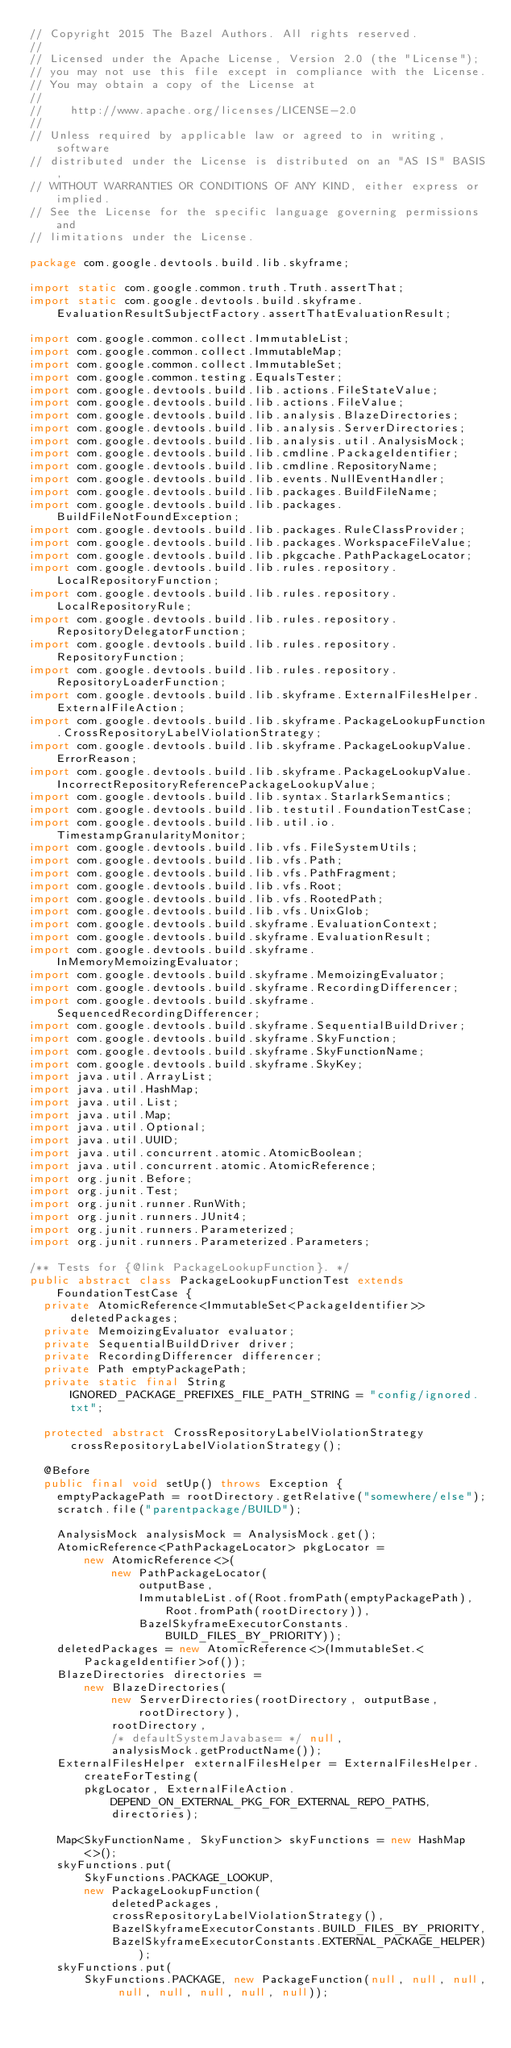Convert code to text. <code><loc_0><loc_0><loc_500><loc_500><_Java_>// Copyright 2015 The Bazel Authors. All rights reserved.
//
// Licensed under the Apache License, Version 2.0 (the "License");
// you may not use this file except in compliance with the License.
// You may obtain a copy of the License at
//
//    http://www.apache.org/licenses/LICENSE-2.0
//
// Unless required by applicable law or agreed to in writing, software
// distributed under the License is distributed on an "AS IS" BASIS,
// WITHOUT WARRANTIES OR CONDITIONS OF ANY KIND, either express or implied.
// See the License for the specific language governing permissions and
// limitations under the License.

package com.google.devtools.build.lib.skyframe;

import static com.google.common.truth.Truth.assertThat;
import static com.google.devtools.build.skyframe.EvaluationResultSubjectFactory.assertThatEvaluationResult;

import com.google.common.collect.ImmutableList;
import com.google.common.collect.ImmutableMap;
import com.google.common.collect.ImmutableSet;
import com.google.common.testing.EqualsTester;
import com.google.devtools.build.lib.actions.FileStateValue;
import com.google.devtools.build.lib.actions.FileValue;
import com.google.devtools.build.lib.analysis.BlazeDirectories;
import com.google.devtools.build.lib.analysis.ServerDirectories;
import com.google.devtools.build.lib.analysis.util.AnalysisMock;
import com.google.devtools.build.lib.cmdline.PackageIdentifier;
import com.google.devtools.build.lib.cmdline.RepositoryName;
import com.google.devtools.build.lib.events.NullEventHandler;
import com.google.devtools.build.lib.packages.BuildFileName;
import com.google.devtools.build.lib.packages.BuildFileNotFoundException;
import com.google.devtools.build.lib.packages.RuleClassProvider;
import com.google.devtools.build.lib.packages.WorkspaceFileValue;
import com.google.devtools.build.lib.pkgcache.PathPackageLocator;
import com.google.devtools.build.lib.rules.repository.LocalRepositoryFunction;
import com.google.devtools.build.lib.rules.repository.LocalRepositoryRule;
import com.google.devtools.build.lib.rules.repository.RepositoryDelegatorFunction;
import com.google.devtools.build.lib.rules.repository.RepositoryFunction;
import com.google.devtools.build.lib.rules.repository.RepositoryLoaderFunction;
import com.google.devtools.build.lib.skyframe.ExternalFilesHelper.ExternalFileAction;
import com.google.devtools.build.lib.skyframe.PackageLookupFunction.CrossRepositoryLabelViolationStrategy;
import com.google.devtools.build.lib.skyframe.PackageLookupValue.ErrorReason;
import com.google.devtools.build.lib.skyframe.PackageLookupValue.IncorrectRepositoryReferencePackageLookupValue;
import com.google.devtools.build.lib.syntax.StarlarkSemantics;
import com.google.devtools.build.lib.testutil.FoundationTestCase;
import com.google.devtools.build.lib.util.io.TimestampGranularityMonitor;
import com.google.devtools.build.lib.vfs.FileSystemUtils;
import com.google.devtools.build.lib.vfs.Path;
import com.google.devtools.build.lib.vfs.PathFragment;
import com.google.devtools.build.lib.vfs.Root;
import com.google.devtools.build.lib.vfs.RootedPath;
import com.google.devtools.build.lib.vfs.UnixGlob;
import com.google.devtools.build.skyframe.EvaluationContext;
import com.google.devtools.build.skyframe.EvaluationResult;
import com.google.devtools.build.skyframe.InMemoryMemoizingEvaluator;
import com.google.devtools.build.skyframe.MemoizingEvaluator;
import com.google.devtools.build.skyframe.RecordingDifferencer;
import com.google.devtools.build.skyframe.SequencedRecordingDifferencer;
import com.google.devtools.build.skyframe.SequentialBuildDriver;
import com.google.devtools.build.skyframe.SkyFunction;
import com.google.devtools.build.skyframe.SkyFunctionName;
import com.google.devtools.build.skyframe.SkyKey;
import java.util.ArrayList;
import java.util.HashMap;
import java.util.List;
import java.util.Map;
import java.util.Optional;
import java.util.UUID;
import java.util.concurrent.atomic.AtomicBoolean;
import java.util.concurrent.atomic.AtomicReference;
import org.junit.Before;
import org.junit.Test;
import org.junit.runner.RunWith;
import org.junit.runners.JUnit4;
import org.junit.runners.Parameterized;
import org.junit.runners.Parameterized.Parameters;

/** Tests for {@link PackageLookupFunction}. */
public abstract class PackageLookupFunctionTest extends FoundationTestCase {
  private AtomicReference<ImmutableSet<PackageIdentifier>> deletedPackages;
  private MemoizingEvaluator evaluator;
  private SequentialBuildDriver driver;
  private RecordingDifferencer differencer;
  private Path emptyPackagePath;
  private static final String IGNORED_PACKAGE_PREFIXES_FILE_PATH_STRING = "config/ignored.txt";

  protected abstract CrossRepositoryLabelViolationStrategy crossRepositoryLabelViolationStrategy();

  @Before
  public final void setUp() throws Exception {
    emptyPackagePath = rootDirectory.getRelative("somewhere/else");
    scratch.file("parentpackage/BUILD");

    AnalysisMock analysisMock = AnalysisMock.get();
    AtomicReference<PathPackageLocator> pkgLocator =
        new AtomicReference<>(
            new PathPackageLocator(
                outputBase,
                ImmutableList.of(Root.fromPath(emptyPackagePath), Root.fromPath(rootDirectory)),
                BazelSkyframeExecutorConstants.BUILD_FILES_BY_PRIORITY));
    deletedPackages = new AtomicReference<>(ImmutableSet.<PackageIdentifier>of());
    BlazeDirectories directories =
        new BlazeDirectories(
            new ServerDirectories(rootDirectory, outputBase, rootDirectory),
            rootDirectory,
            /* defaultSystemJavabase= */ null,
            analysisMock.getProductName());
    ExternalFilesHelper externalFilesHelper = ExternalFilesHelper.createForTesting(
        pkgLocator, ExternalFileAction.DEPEND_ON_EXTERNAL_PKG_FOR_EXTERNAL_REPO_PATHS, directories);

    Map<SkyFunctionName, SkyFunction> skyFunctions = new HashMap<>();
    skyFunctions.put(
        SkyFunctions.PACKAGE_LOOKUP,
        new PackageLookupFunction(
            deletedPackages,
            crossRepositoryLabelViolationStrategy(),
            BazelSkyframeExecutorConstants.BUILD_FILES_BY_PRIORITY,
            BazelSkyframeExecutorConstants.EXTERNAL_PACKAGE_HELPER));
    skyFunctions.put(
        SkyFunctions.PACKAGE, new PackageFunction(null, null, null, null, null, null, null, null));</code> 